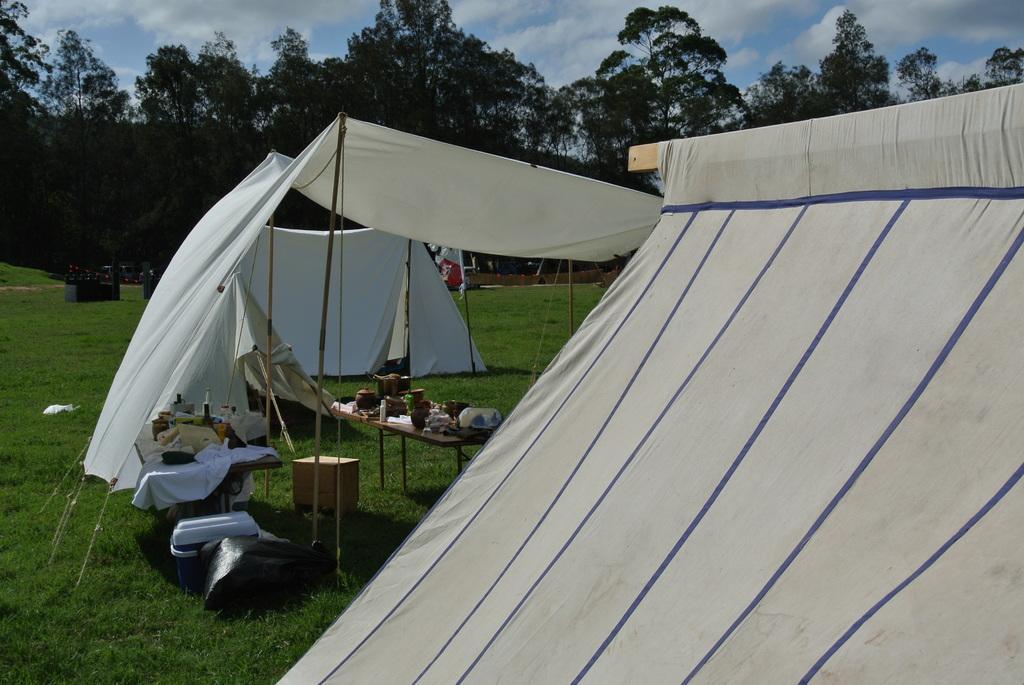Describe this image in one or two sentences. In this image in front there are tents and under the tents there are tables and on top of the tables there are few objects. At the bottom of the image there is grass on the surface. In the background there are trees and sky. 